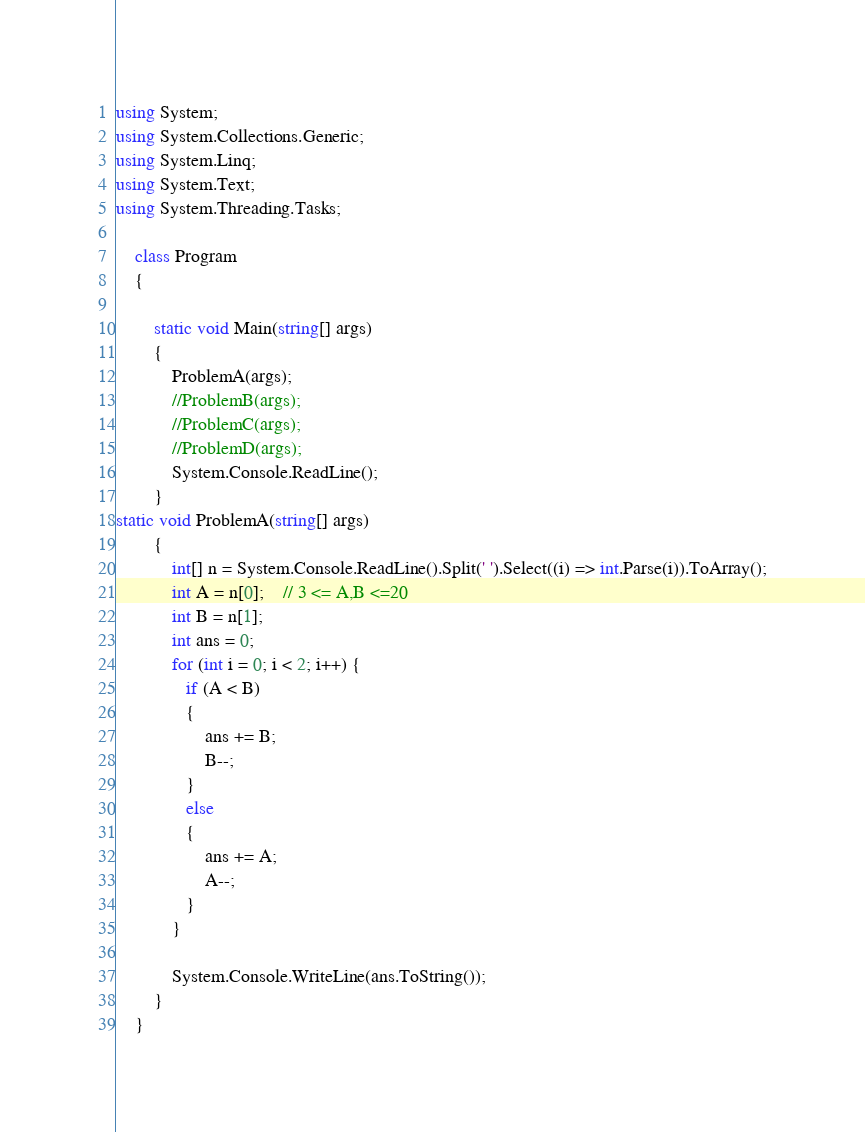Convert code to text. <code><loc_0><loc_0><loc_500><loc_500><_C#_>using System;
using System.Collections.Generic;
using System.Linq;
using System.Text;
using System.Threading.Tasks;

    class Program
    {

        static void Main(string[] args)
        {
            ProblemA(args);
            //ProblemB(args);
            //ProblemC(args);
            //ProblemD(args);
            System.Console.ReadLine();
        }
static void ProblemA(string[] args)
        {
            int[] n = System.Console.ReadLine().Split(' ').Select((i) => int.Parse(i)).ToArray();
            int A = n[0];    // 3 <= A,B <=20
            int B = n[1];
            int ans = 0;
            for (int i = 0; i < 2; i++) { 
               if (A < B)
               {
                   ans += B;
                   B--;
               }
               else
               {
                   ans += A;
                   A--;
               }
            }

            System.Console.WriteLine(ans.ToString());
        }
	}</code> 